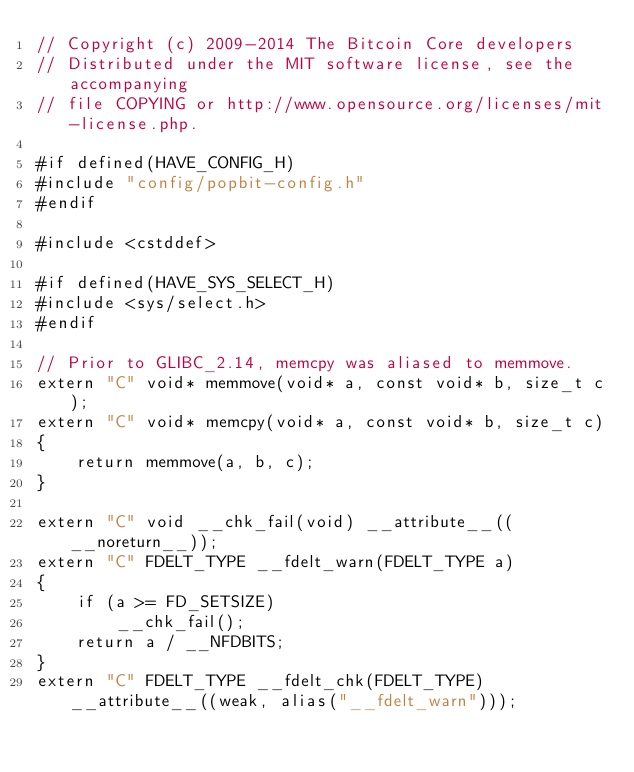Convert code to text. <code><loc_0><loc_0><loc_500><loc_500><_C++_>// Copyright (c) 2009-2014 The Bitcoin Core developers
// Distributed under the MIT software license, see the accompanying
// file COPYING or http://www.opensource.org/licenses/mit-license.php.

#if defined(HAVE_CONFIG_H)
#include "config/popbit-config.h"
#endif

#include <cstddef>

#if defined(HAVE_SYS_SELECT_H)
#include <sys/select.h>
#endif

// Prior to GLIBC_2.14, memcpy was aliased to memmove.
extern "C" void* memmove(void* a, const void* b, size_t c);
extern "C" void* memcpy(void* a, const void* b, size_t c)
{
    return memmove(a, b, c);
}

extern "C" void __chk_fail(void) __attribute__((__noreturn__));
extern "C" FDELT_TYPE __fdelt_warn(FDELT_TYPE a)
{
    if (a >= FD_SETSIZE)
        __chk_fail();
    return a / __NFDBITS;
}
extern "C" FDELT_TYPE __fdelt_chk(FDELT_TYPE) __attribute__((weak, alias("__fdelt_warn")));
</code> 